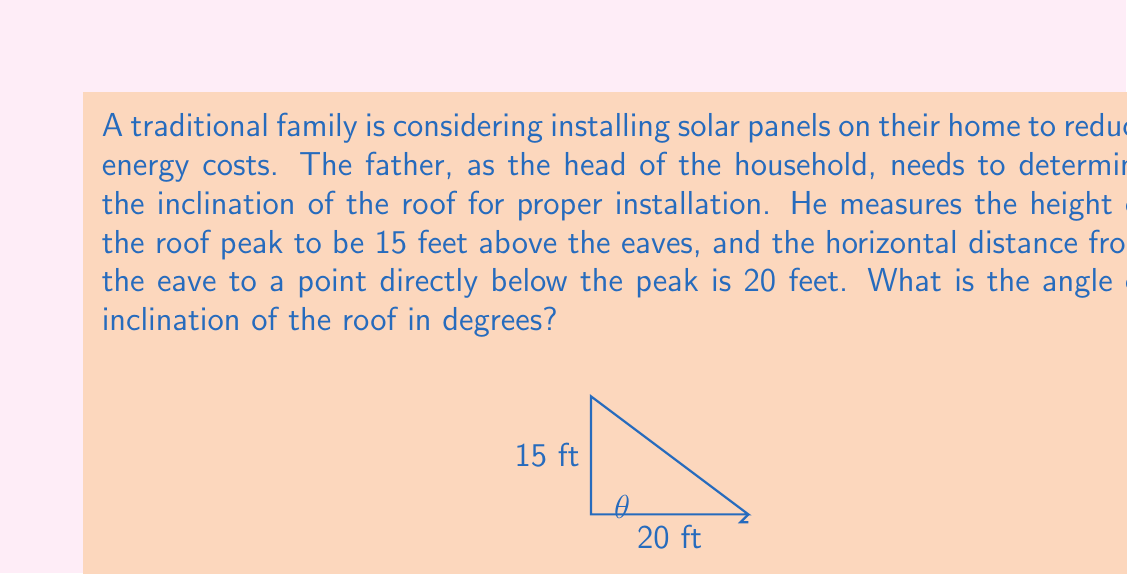Help me with this question. To solve this problem, we can use basic trigonometry. The roof forms a right triangle, where:
- The adjacent side is the horizontal distance from the eave to the point below the peak (20 feet)
- The opposite side is the height of the roof peak above the eaves (15 feet)
- The hypotenuse is the length of the roof from eave to peak
- The angle we're looking for is the one formed at the eave between the horizontal and the roof line

We can use the tangent function to find this angle:

$$ \tan(\theta) = \frac{\text{opposite}}{\text{adjacent}} = \frac{15}{20} = 0.75 $$

To find the angle $\theta$, we need to use the inverse tangent (arctan or $\tan^{-1}$):

$$ \theta = \tan^{-1}(0.75) $$

Using a calculator or trigonometric tables:

$$ \theta \approx 36.87^\circ $$

Therefore, the angle of inclination of the roof is approximately 36.87 degrees.
Answer: The angle of inclination of the roof is approximately $36.87^\circ$. 